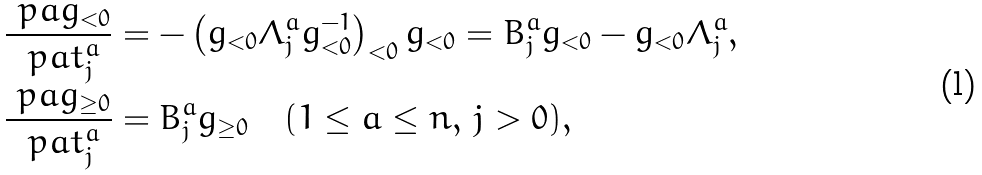Convert formula to latex. <formula><loc_0><loc_0><loc_500><loc_500>\frac { \ p a g _ { < 0 } } { \ p a t _ { j } ^ { a } } & = - \left ( g _ { < 0 } \Lambda _ { j } ^ { a } g _ { < 0 } ^ { - 1 } \right ) _ { < 0 } g _ { < 0 } = B _ { j } ^ { a } g _ { < 0 } - g _ { < 0 } \Lambda _ { j } ^ { a } , \\ \frac { \ p a g _ { \geq 0 } } { \ p a t _ { j } ^ { a } } & = B _ { j } ^ { a } g _ { \geq 0 } \quad ( 1 \leq a \leq n , \, j > 0 ) ,</formula> 